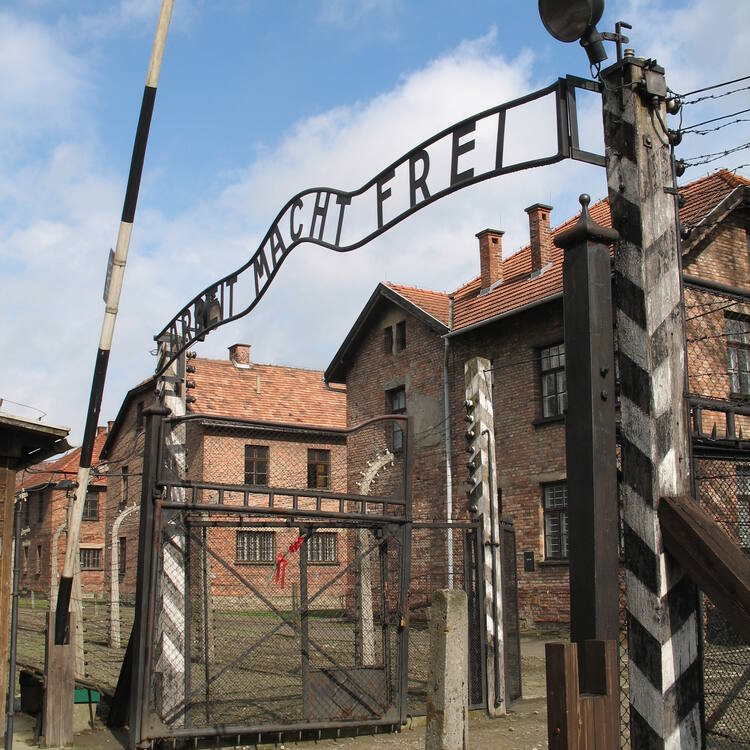How does the architecture of the buildings behind the gate reflect the history of this place? The buildings behind the gate at Auschwitz are made of stark, red bricks and have a utilitarian design, reflecting their grim purpose. These austere structures housed the countless prisoners who were subjected to forced labor, inhumane conditions, and torturous treatment. The barbed wire fences that surround the complex further emphasize the oppressive and confining nature of the camp. The architecture's cold and unembellished appearance is a stark reminder of the cruelty and the industrial efficiency with which the atrocities were carried out. 